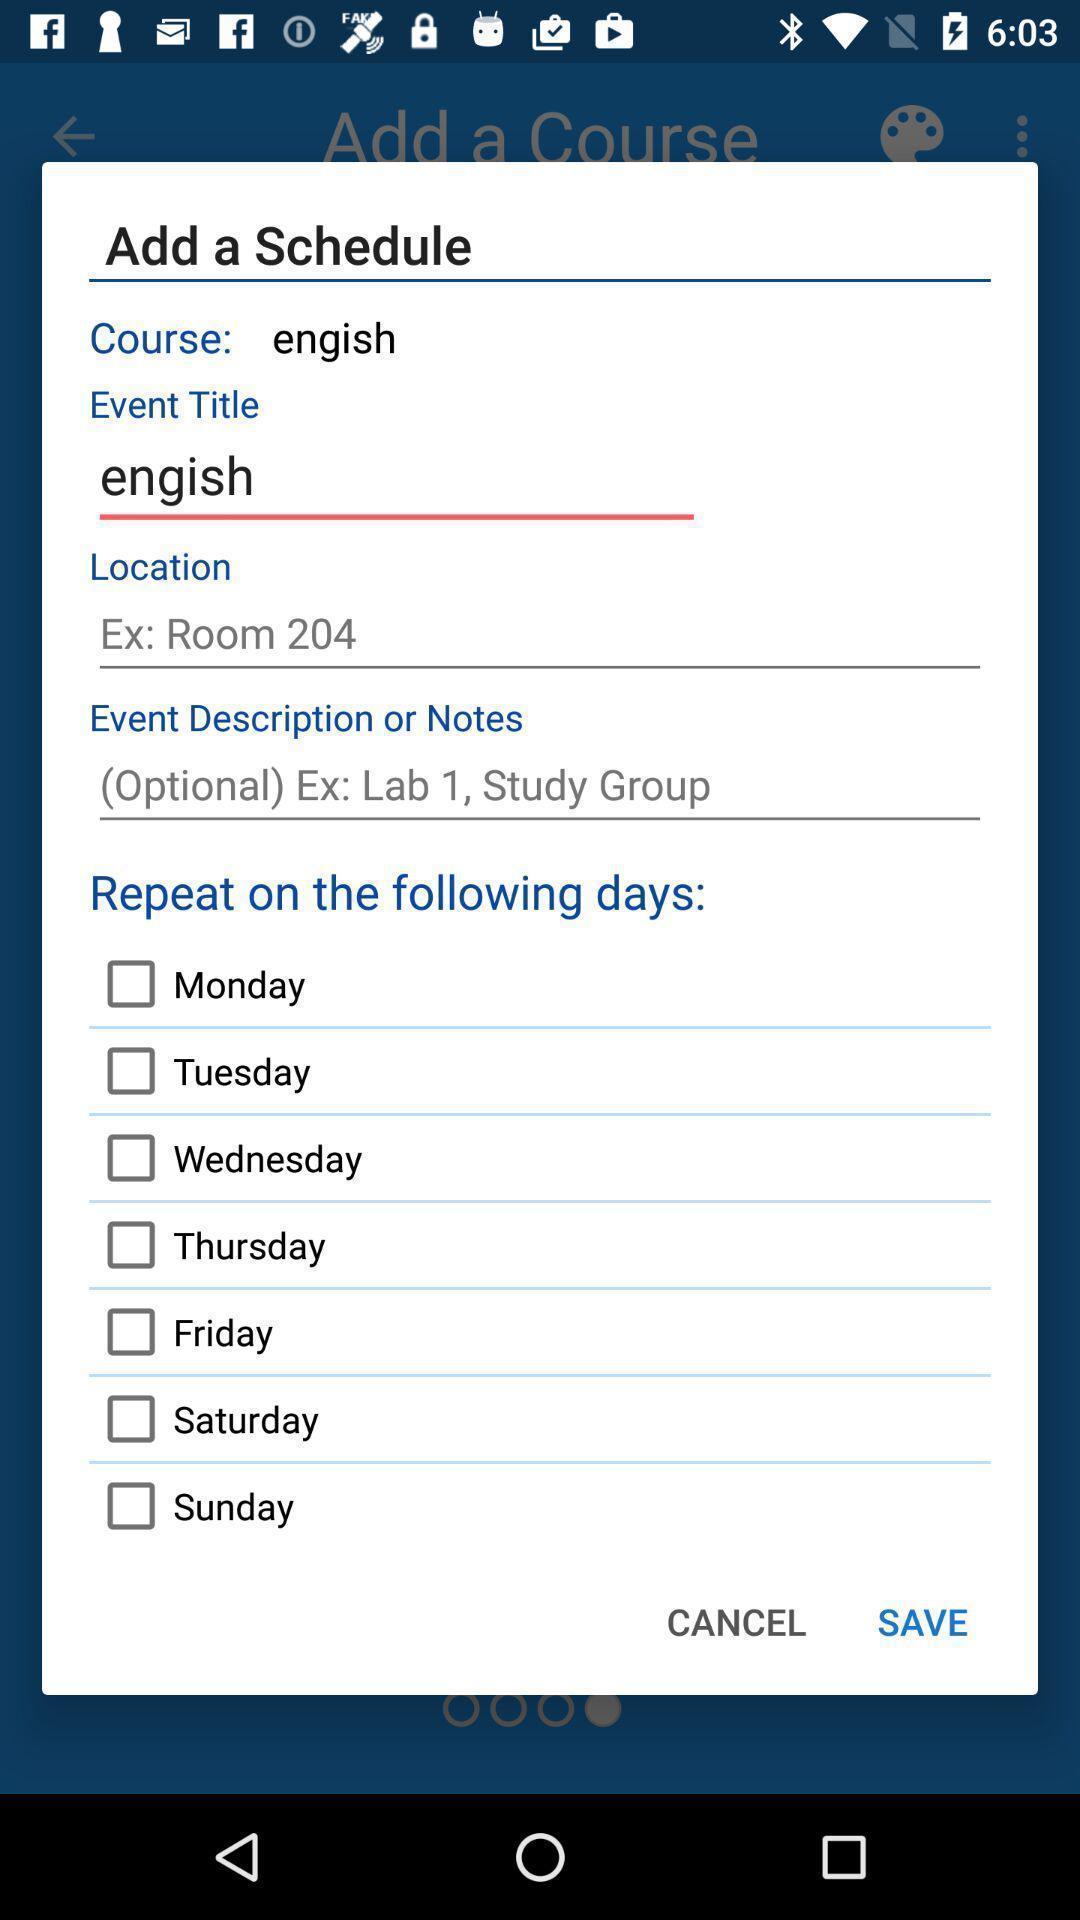Tell me about the visual elements in this screen capture. Schedule notification of a course app. 